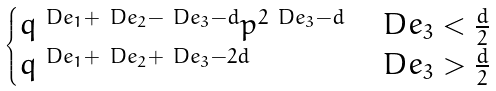Convert formula to latex. <formula><loc_0><loc_0><loc_500><loc_500>\begin{cases} q ^ { \ D e _ { 1 } + \ D e _ { 2 } - \ D e _ { 3 } - d } p ^ { 2 \ D e _ { 3 } - d } & \ D e _ { 3 } < \frac { d } { 2 } \\ q ^ { \ D e _ { 1 } + \ D e _ { 2 } + \ D e _ { 3 } - 2 d } & \ D e _ { 3 } > \frac { d } { 2 } \end{cases}</formula> 